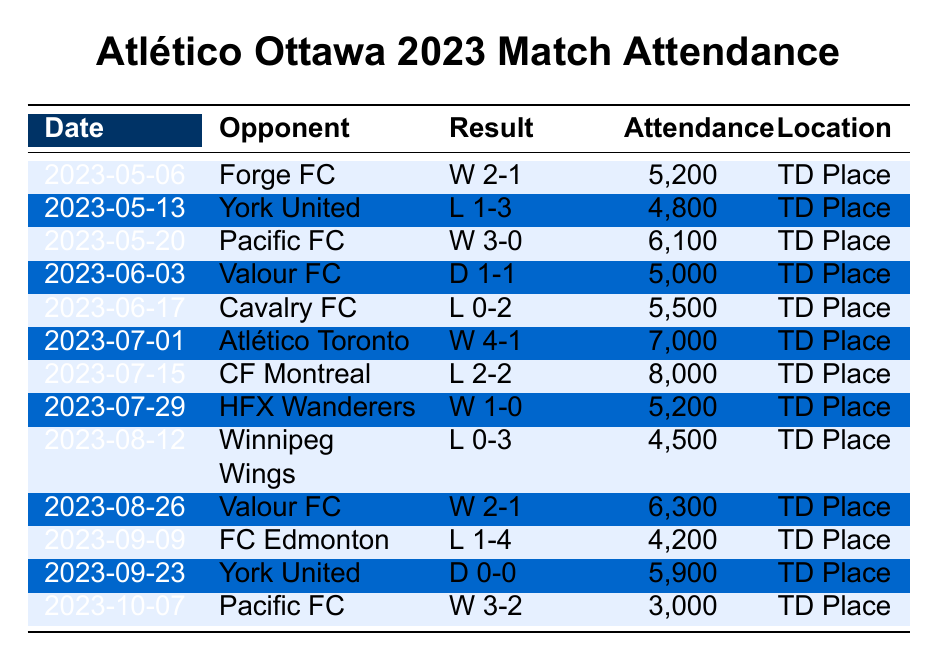What was the maximum attendance for Atlético Ottawa during the 2023 season? The highest recorded attendance in the table is 8,000, which occurred on July 15 against CF Montreal.
Answer: 8,000 What was the attendance at the match against Forge FC on May 6, 2023? The attendance for the match against Forge FC on May 6, 2023, is listed as 5,200.
Answer: 5,200 How many matches did Atlético Ottawa play in front of more than 6,000 fans? The matches with more than 6,000 fans were on May 20 (6,100), July 1 (7,000), July 15 (8,000), and August 26 (6,300). That totals 4 matches.
Answer: 4 What was the average attendance for Atlético Ottawa across all matches? To find the average, we sum all attendance figures: (5200 + 4800 + 6100 + 5000 + 5500 + 7000 + 8000 + 5200 + 4500 + 6300 + 4200 + 5900 + 3000) = 62,800. There are 13 matches, so the average is 62,800 / 13 = 4,840.
Answer: 4,840 Did Atlético Ottawa ever have a match where attendance was lower than 4,500? Checking the table, the lowest attendance recorded is 3,000 on October 7, which is indeed less than 4,500.
Answer: Yes What was the attendance difference between the match against York United on May 13 and the match against Pacific FC on May 20? The attendance against York United on May 13 was 4,800, and against Pacific FC on May 20, it was 6,100. The difference is 6,100 - 4,800 = 1,300.
Answer: 1,300 How many matches ended in a draw, and what was the average attendance of those matches? There were two draws in the table: one on June 3 (5,000) and another on September 23 (5,900). Their average attendance is (5,000 + 5,900) / 2 = 5,450.
Answer: 5,450 What percentage of matches resulted in a win for Atlético Ottawa? Atlético Ottawa won 6 matches out of 13. To find the percentage, (6/13) * 100 ≈ 46.15%.
Answer: Approximately 46.15% Which opponent did Atlético Ottawa have their lowest attendance against, and what was that attendance? The lowest attendance was against Pacific FC on October 7, with only 3,000 fans present.
Answer: Pacific FC, 3,000 Was there any match in which Atlético Ottawa scored fewer than two goals? Yes, the matches on May 13 (L 1-3 against York United), June 17 (L 0-2 against Cavalry FC), August 12 (L 0-3 against Winnipeg Wings), and September 9 (L 1-4 against FC Edmonton) had fewer than two goals scored.
Answer: Yes 